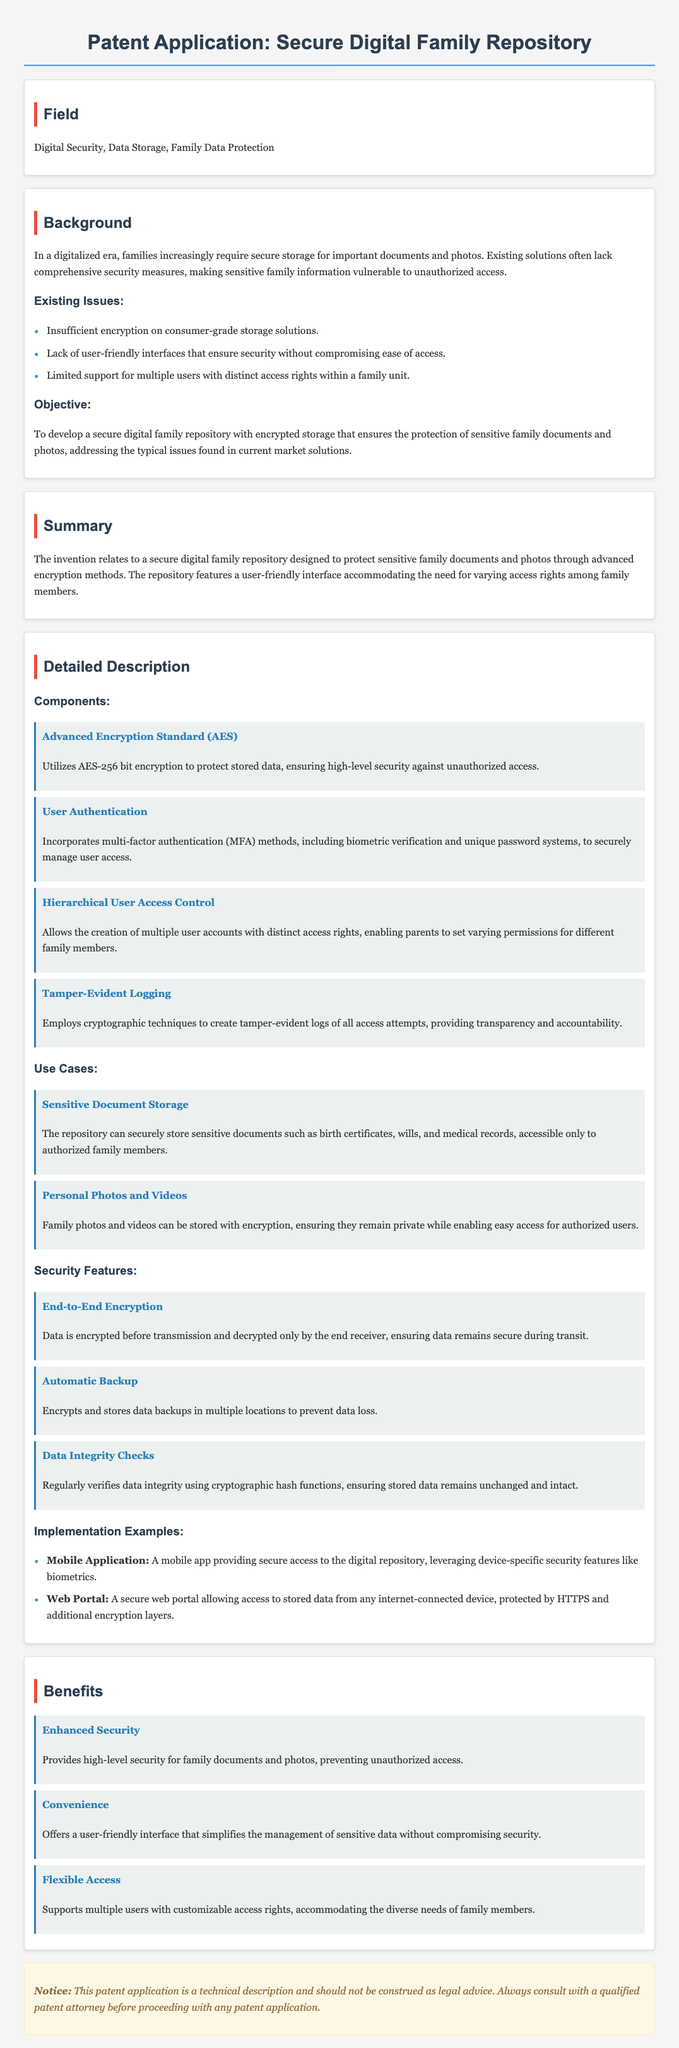What is the encryption standard used? The document specifies that the Advanced Encryption Standard (AES) is utilized, particularly AES-256 bit encryption, for securing data.
Answer: AES-256 What are the multi-factor authentication methods? The document mentions that the repository includes biometric verification and unique password systems as methods for multi-factor authentication.
Answer: Biometric verification and unique password systems How many user access levels can be created? The description of hierarchical user access control indicates the capability to create multiple user accounts with distinct access rights.
Answer: Multiple What is the primary objective of the invention? The document states that the objective is to develop a secure digital family repository with encrypted storage for protecting sensitive family documents and photos.
Answer: Protecting sensitive family documents and photos What feature ensures data is secure during transmission? The feature described in the document that ensures data remains secure during transit is end-to-end encryption.
Answer: End-to-end encryption What type of documents can be securely stored? The document indicates that sensitive documents such as birth certificates, wills, and medical records can be securely stored within the repository.
Answer: Birth certificates, wills, and medical records How are data integrity checks performed? The document explains that data integrity checks are regularly performed using cryptographic hash functions to ensure the data remains unchanged and intact.
Answer: Cryptographic hash functions What type of application is mentioned for secure access? The document includes a mention of a mobile application that provides secure access to the digital repository.
Answer: Mobile application What is the warning at the end of the document about? The warning emphasizes that the patent application is a technical description and should not be construed as legal advice, recommending consultation with a qualified patent attorney.
Answer: Legal advice statement 